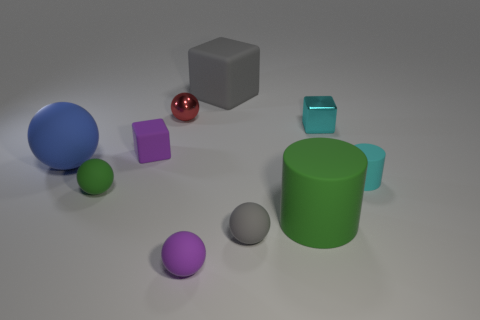Subtract all yellow cubes. Subtract all cyan spheres. How many cubes are left? 3 Subtract all cylinders. How many objects are left? 8 Subtract all big brown spheres. Subtract all cyan cylinders. How many objects are left? 9 Add 1 cyan rubber objects. How many cyan rubber objects are left? 2 Add 4 large blue objects. How many large blue objects exist? 5 Subtract 0 yellow spheres. How many objects are left? 10 